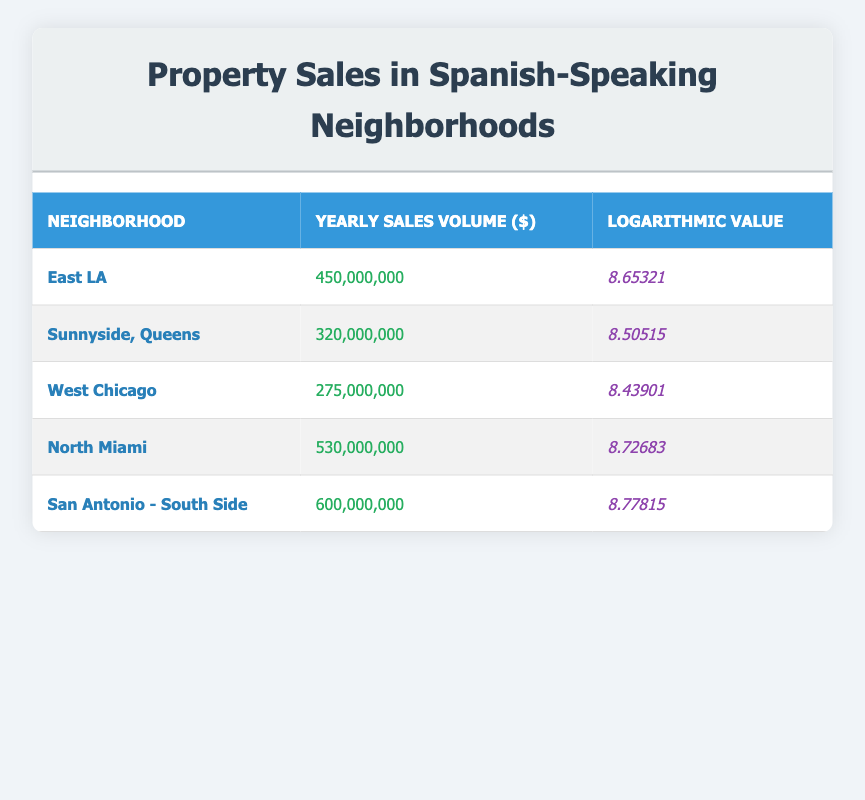What is the yearly sales volume for North Miami? The table shows that the yearly sales volume for North Miami is listed directly in the corresponding row. According to the table, it is 530,000,000.
Answer: 530,000,000 Which neighborhood has the highest yearly sales volume? The table provides the yearly sales volumes for all neighborhoods. By comparing the values, I found San Antonio - South Side has the highest sales volume at 600,000,000.
Answer: San Antonio - South Side What is the logarithmic value for West Chicago? The logarithmic value for West Chicago is mentioned in the table, indicated in the corresponding row. It is 8.43901.
Answer: 8.43901 Calculate the total yearly sales volume for East LA and Sunnyside, Queens. The yearly sales volume for East LA is 450,000,000, and for Sunnyside, Queens, it is 320,000,000. Adding these: 450,000,000 + 320,000,000 = 770,000,000.
Answer: 770,000,000 Is the logarithmic value for North Miami greater than that of West Chicago? According to the table, North Miami has a logarithmic value of 8.72683, while West Chicago has a value of 8.43901. Comparing these, 8.72683 > 8.43901, so the statement is true.
Answer: Yes What is the average yearly sales volume of all mentioned neighborhoods? The yearly sales volumes are: 450,000,000 (East LA), 320,000,000 (Sunnyside, Queens), 275,000,000 (West Chicago), 530,000,000 (North Miami), and 600,000,000 (San Antonio - South Side). The total is 450,000,000 + 320,000,000 + 275,000,000 + 530,000,000 + 600,000,000 = 2,175,000,000. There are 5 neighborhoods, so the average is 2,175,000,000 / 5 = 435,000,000.
Answer: 435,000,000 What is the difference in logarithmic values between San Antonio - South Side and East LA? San Antonio - South Side has a logarithmic value of 8.77815, and East LA has 8.65321. The difference is calculated as 8.77815 - 8.65321 = 0.12494.
Answer: 0.12494 Is it true that Sunnyside, Queens has a higher logarithmic value than West Chicago? By examining the values, Sunnyside, Queens has a logarithmic value of 8.50515, while West Chicago has 8.43901. Therefore, comparing the two, 8.50515 > 8.43901 makes the statement true.
Answer: Yes Which neighborhood has the second highest yearly sales volume? Sorting the yearly sales volume from highest to lowest shows that after San Antonio - South Side (600,000,000), the second highest is North Miami with 530,000,000.
Answer: North Miami 